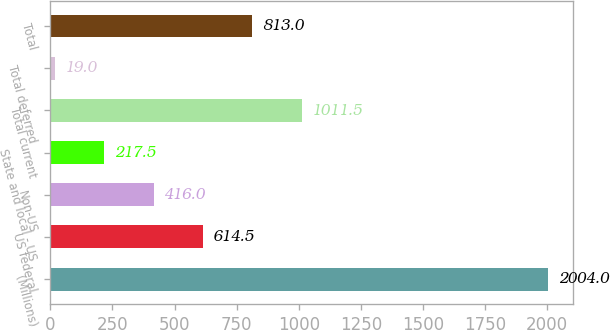Convert chart. <chart><loc_0><loc_0><loc_500><loc_500><bar_chart><fcel>(Millions)<fcel>US federal<fcel>Non-US<fcel>State and local - US<fcel>Total current<fcel>Total deferred<fcel>Total<nl><fcel>2004<fcel>614.5<fcel>416<fcel>217.5<fcel>1011.5<fcel>19<fcel>813<nl></chart> 